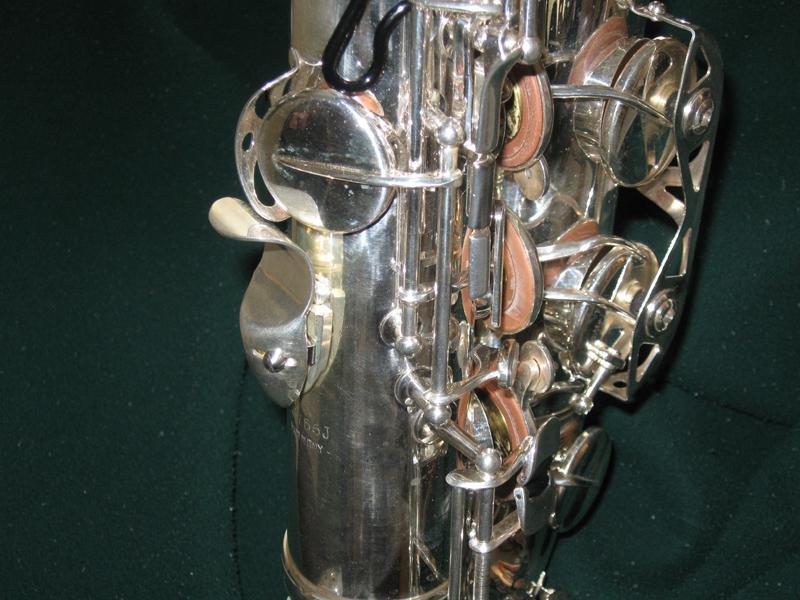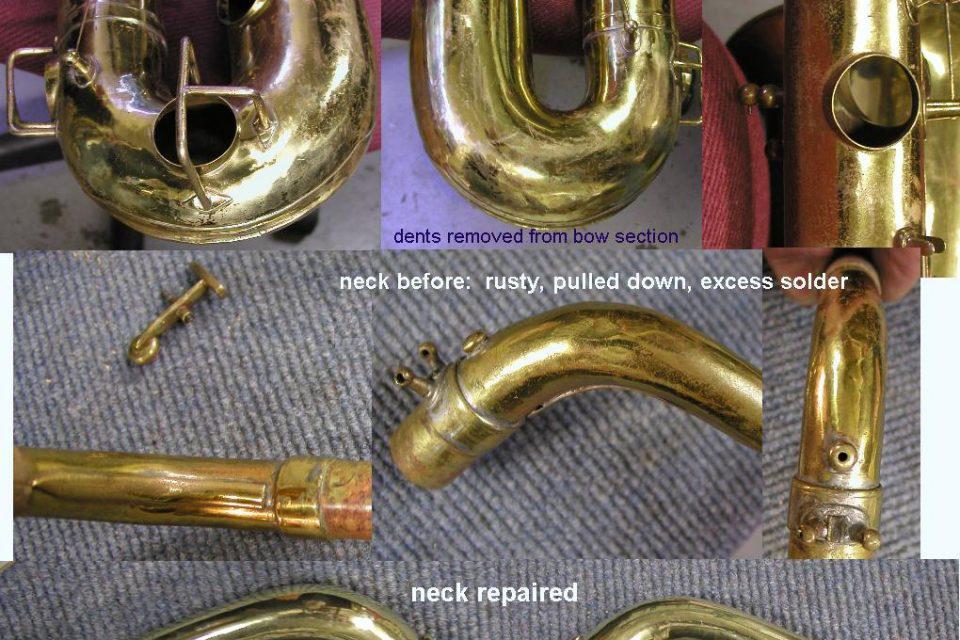The first image is the image on the left, the second image is the image on the right. For the images shown, is this caption "Someone is playing a sax." true? Answer yes or no. No. The first image is the image on the left, the second image is the image on the right. Assess this claim about the two images: "One image shows a man playing a saxophone and standing in front of a row of upright instruments.". Correct or not? Answer yes or no. No. 